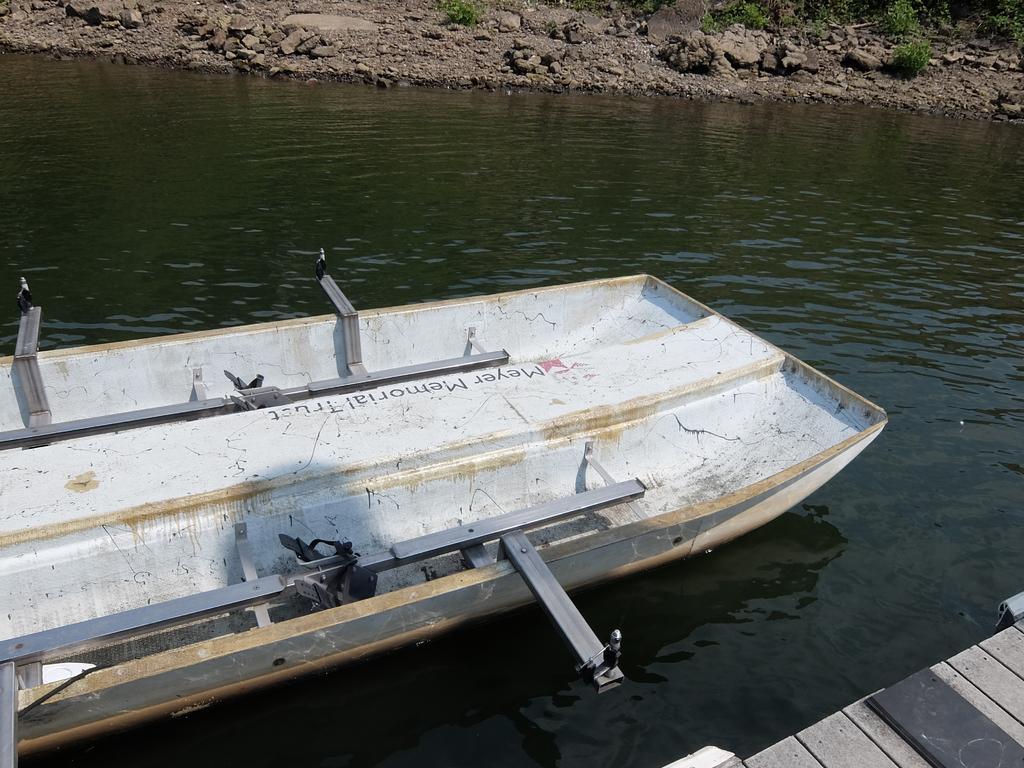Could you give a brief overview of what you see in this image? In this picture there is a white color boat in the river water. Behind there are some rocks on the ground. 